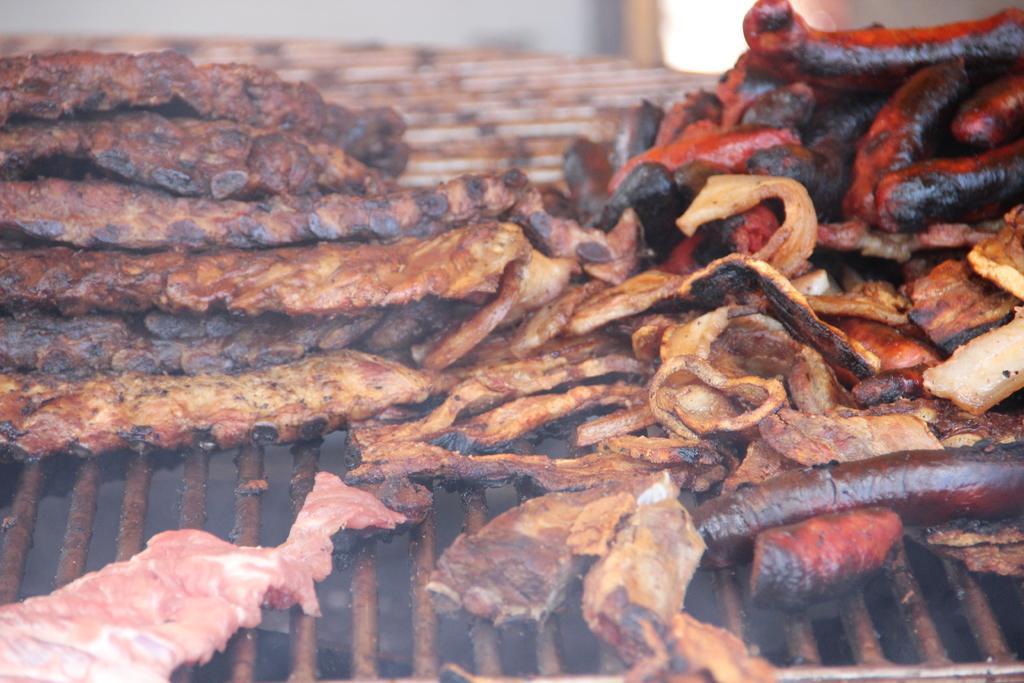How would you summarize this image in a sentence or two? In this image I can see the metal grill and on the grill I can see few food items which are brown and black in color. I can see the blurry background. 